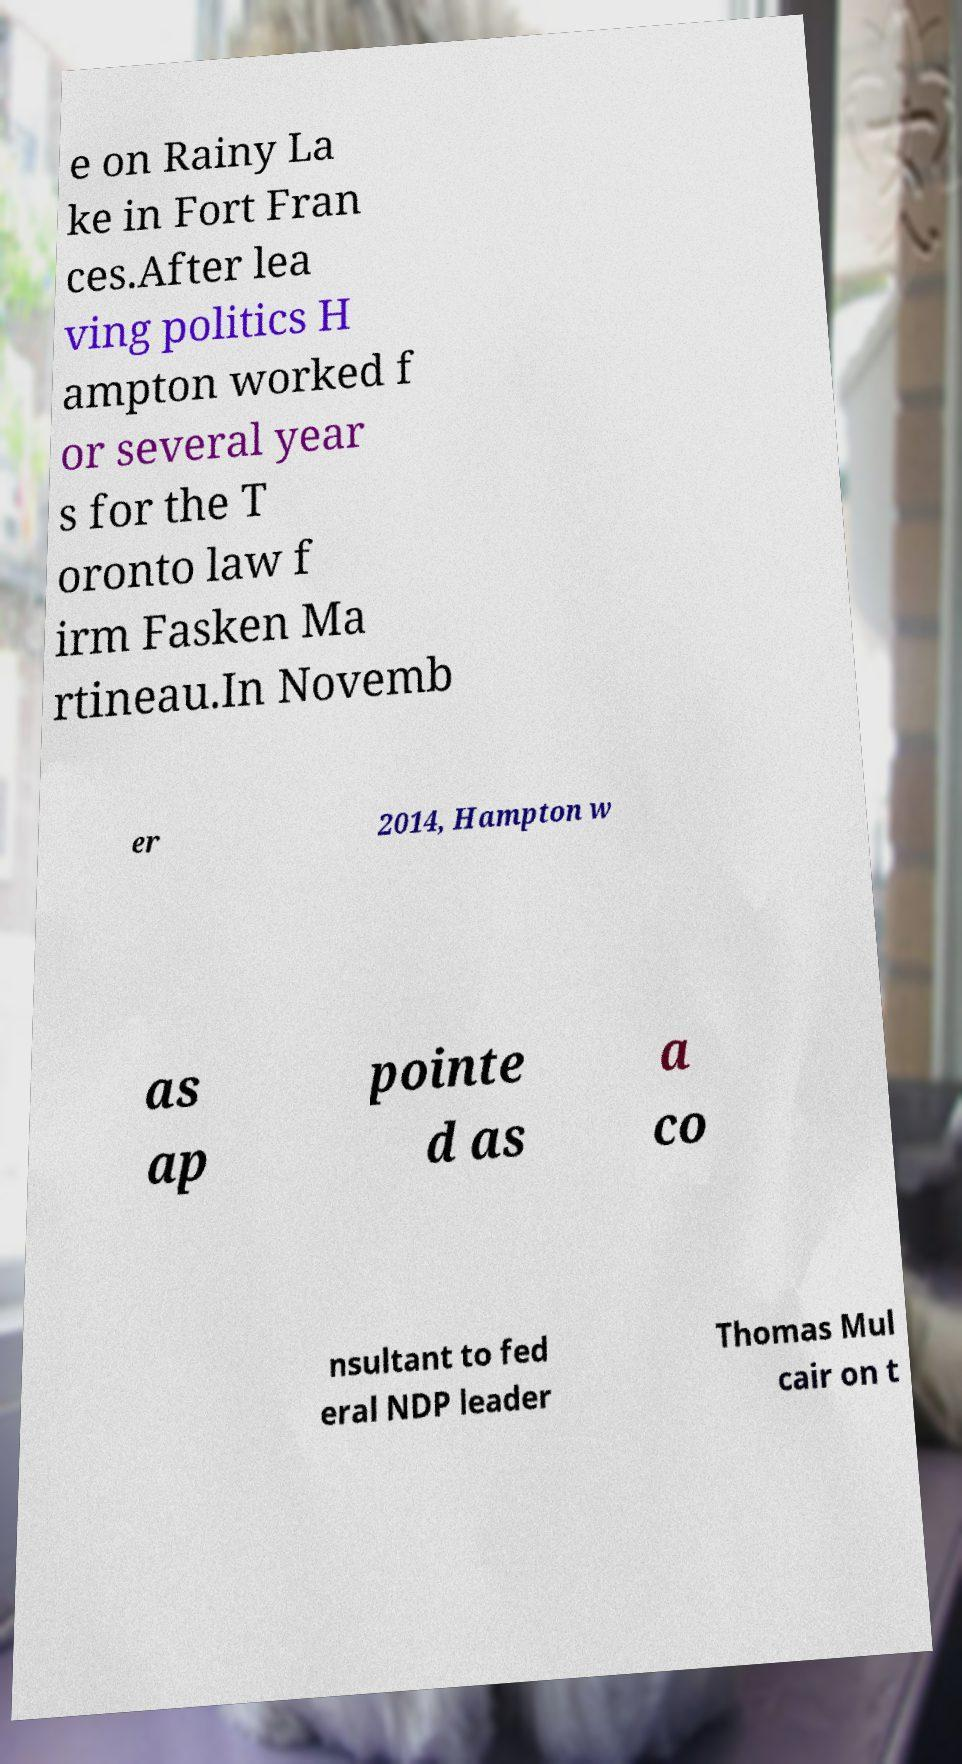Could you extract and type out the text from this image? e on Rainy La ke in Fort Fran ces.After lea ving politics H ampton worked f or several year s for the T oronto law f irm Fasken Ma rtineau.In Novemb er 2014, Hampton w as ap pointe d as a co nsultant to fed eral NDP leader Thomas Mul cair on t 